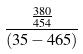<formula> <loc_0><loc_0><loc_500><loc_500>\frac { \frac { 3 8 0 } { 4 5 4 } } { ( 3 5 - 4 6 5 ) }</formula> 